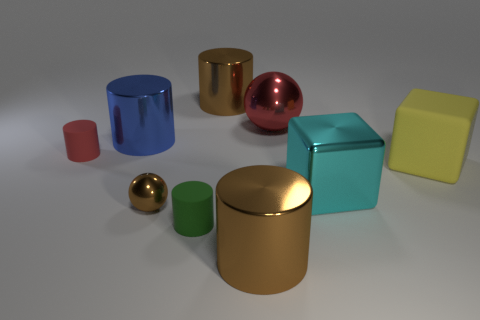Does the big metal sphere have the same color as the big metal cylinder that is in front of the small red thing?
Offer a very short reply. No. The small object that is the same color as the large metallic sphere is what shape?
Your response must be concise. Cylinder. What material is the blue object right of the red object that is on the left side of the large shiny thing to the left of the tiny ball?
Ensure brevity in your answer.  Metal. There is a red object that is to the right of the tiny red object; is its shape the same as the large blue metal thing?
Offer a terse response. No. What material is the tiny cylinder that is behind the big cyan shiny thing?
Your answer should be compact. Rubber. How many metallic objects are tiny green things or small purple cubes?
Your answer should be compact. 0. Are there any blue metal things of the same size as the green cylinder?
Make the answer very short. No. Is the number of yellow objects that are in front of the big cyan metal block greater than the number of large brown objects?
Provide a succinct answer. No. What number of tiny objects are blocks or brown blocks?
Your answer should be compact. 0. How many other big blue objects have the same shape as the blue object?
Provide a succinct answer. 0. 